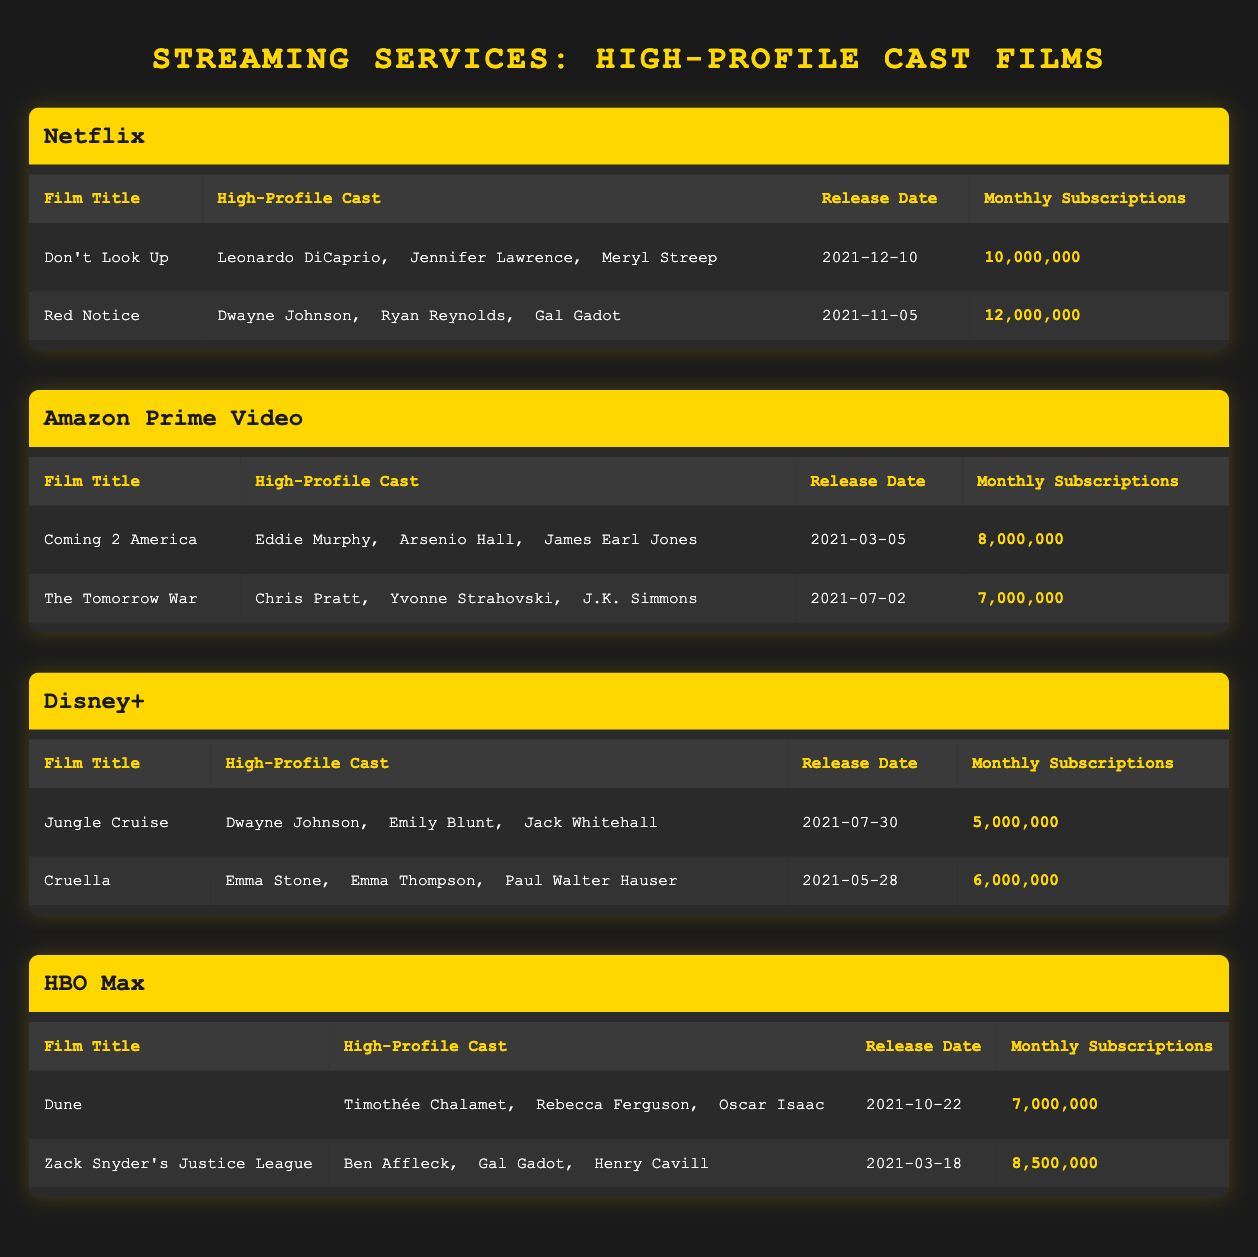What film on HBO Max has the highest monthly subscriptions? Looking at the subscriptions from HBO Max, "Zack Snyder's Justice League" has 8,500,000 monthly subscriptions, which is higher than "Dune" with 7,000,000. Therefore, "Zack Snyder's Justice League" is the film with the highest subscriptions on HBO Max.
Answer: Zack Snyder's Justice League Which streaming service had the lowest total monthly subscriptions from high-profile cast films? To find which service had the lowest total monthly subscriptions, we sum each service's subscriptions: Netflix (22,000,000), Amazon Prime Video (15,000,000), Disney+ (11,000,000), and HBO Max (15,500,000). The lowest total is from Disney+ with 11,000,000 subscriptions.
Answer: Disney+ Is "Don't Look Up" the only film on Netflix that features Meryl Streep? By checking the listed films under Netflix, "Don't Look Up" features Meryl Streep, while "Red Notice" does not have her in its cast. Therefore, "Don't Look Up" is indeed the only film on Netflix that features Meryl Streep.
Answer: Yes Which actor appears in two different films across two different services? By examining the cast of each film, we see that Dwayne Johnson appears in "Red Notice" on Netflix and "Jungle Cruise" on Disney+. This confirms he is the actor appearing in two different films across different services.
Answer: Dwayne Johnson What is the average monthly subscription count for films on Amazon Prime Video? For Amazon Prime Video, we have two films: "Coming 2 America" with 8,000,000 subscriptions and "The Tomorrow War" with 7,000,000. The average is calculated by summing these two (8,000,000 + 7,000,000 = 15,000,000) and dividing by 2, yielding an average of 7,500,000 subscriptions.
Answer: 7,500,000 